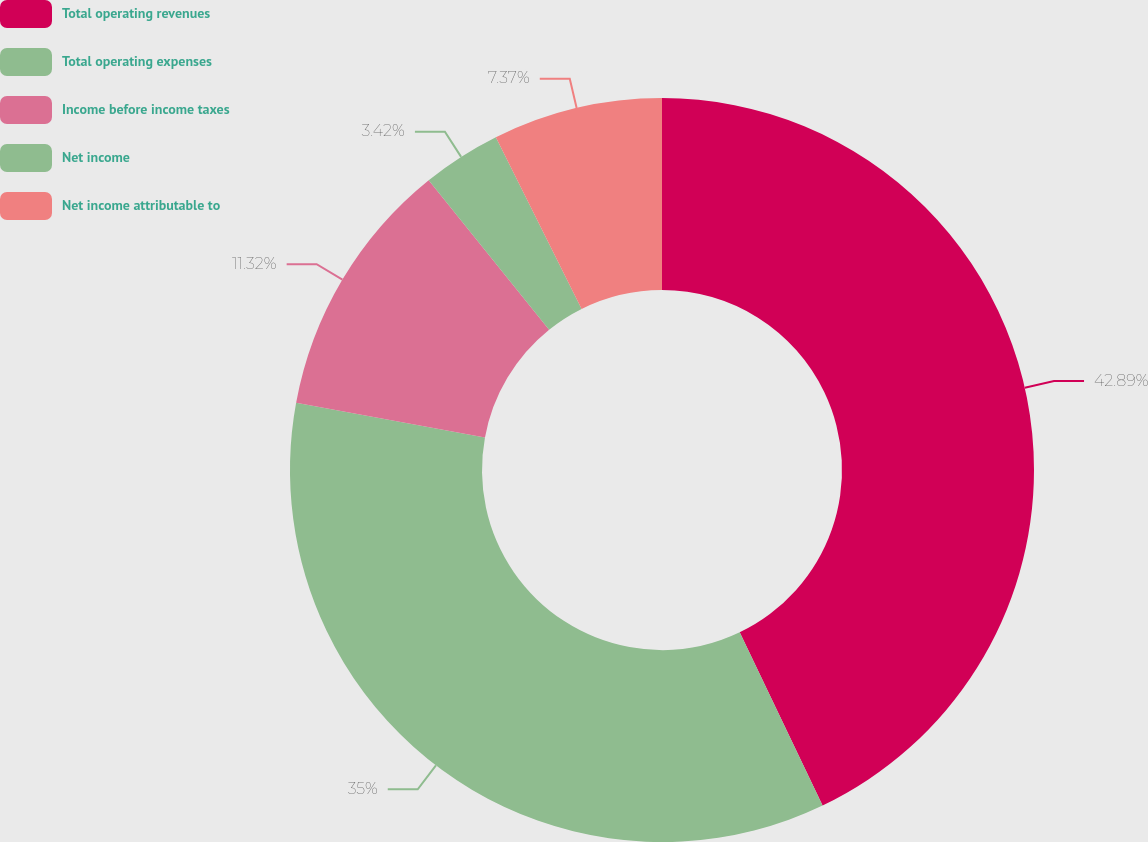Convert chart to OTSL. <chart><loc_0><loc_0><loc_500><loc_500><pie_chart><fcel>Total operating revenues<fcel>Total operating expenses<fcel>Income before income taxes<fcel>Net income<fcel>Net income attributable to<nl><fcel>42.9%<fcel>35.0%<fcel>11.32%<fcel>3.42%<fcel>7.37%<nl></chart> 